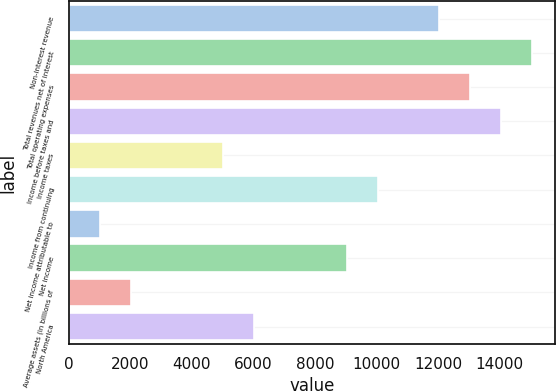Convert chart to OTSL. <chart><loc_0><loc_0><loc_500><loc_500><bar_chart><fcel>Non-interest revenue<fcel>Total revenues net of interest<fcel>Total operating expenses<fcel>Income before taxes and<fcel>Income taxes<fcel>Income from continuing<fcel>Net income attributable to<fcel>Net income<fcel>Average assets (in billions of<fcel>North America<nl><fcel>12038.3<fcel>15044.7<fcel>13040.4<fcel>14042.6<fcel>5023.3<fcel>10034<fcel>1014.74<fcel>9031.86<fcel>2016.88<fcel>6025.44<nl></chart> 